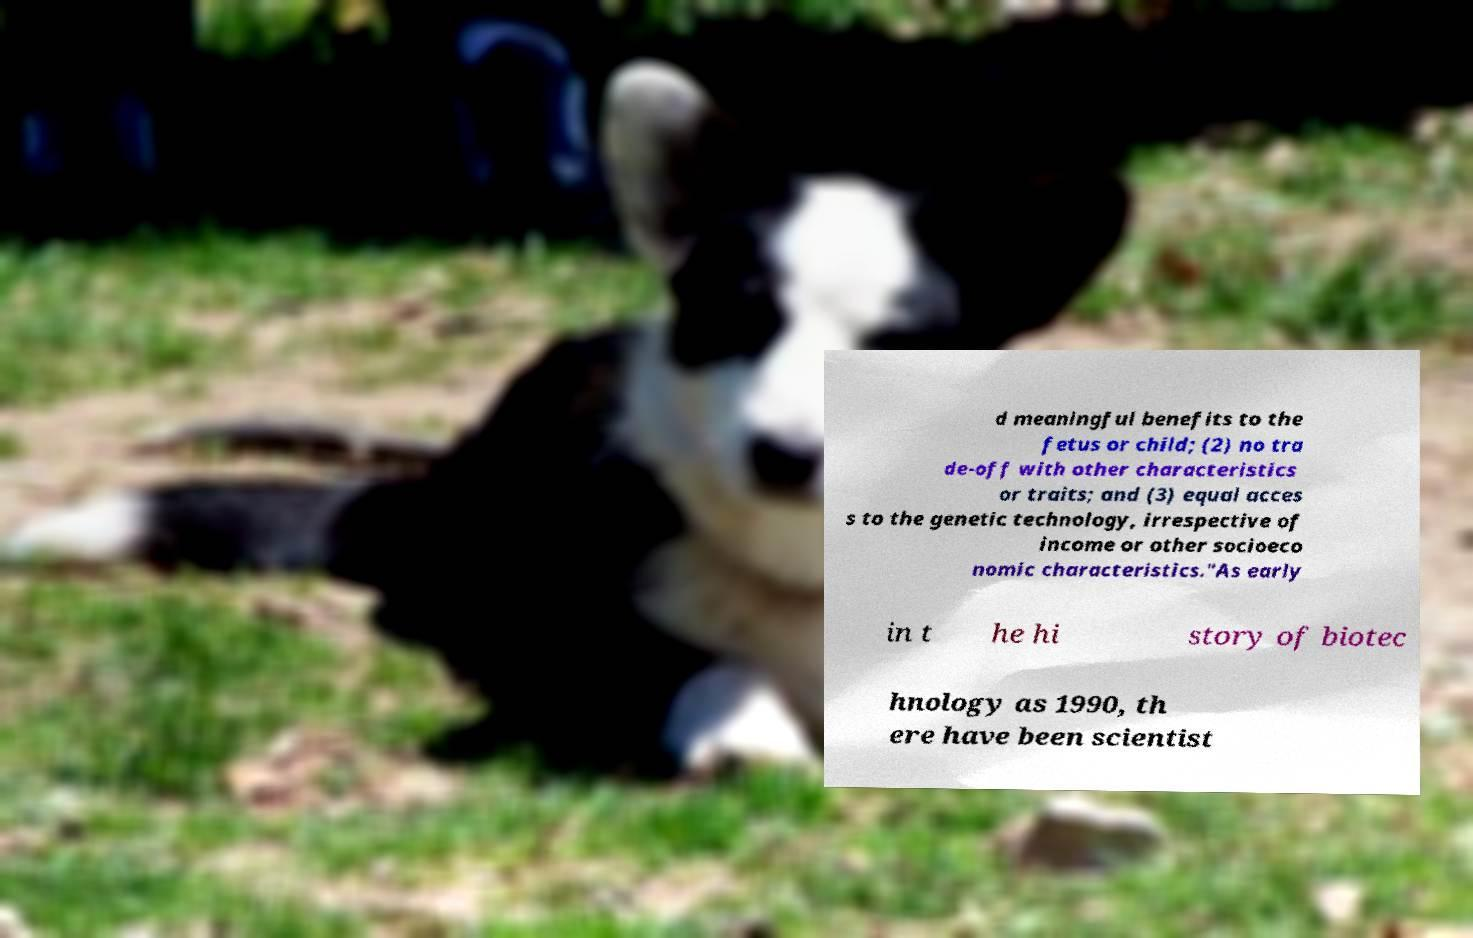Could you assist in decoding the text presented in this image and type it out clearly? d meaningful benefits to the fetus or child; (2) no tra de-off with other characteristics or traits; and (3) equal acces s to the genetic technology, irrespective of income or other socioeco nomic characteristics."As early in t he hi story of biotec hnology as 1990, th ere have been scientist 